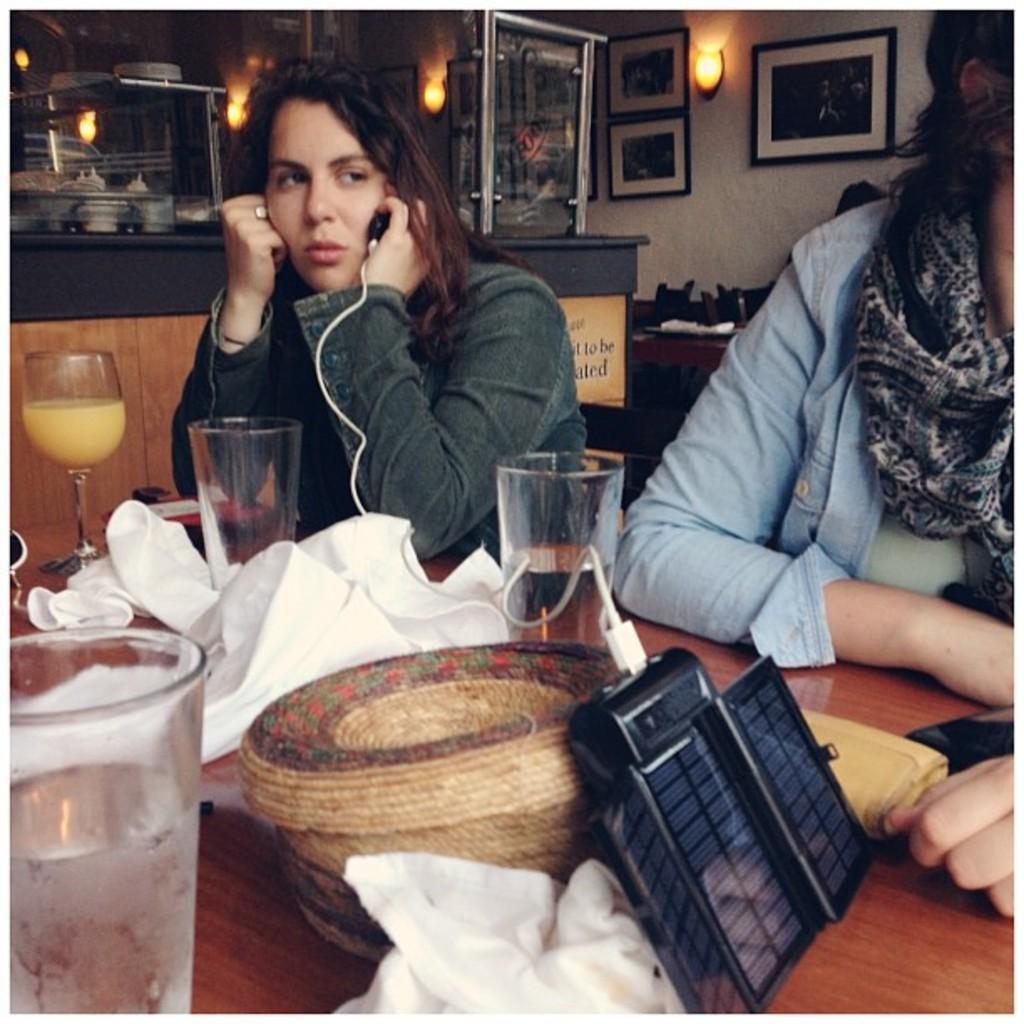Describe this image in one or two sentences. In this image I can see two people sitting in chairs in front of them there is a table on which I can see some glasses with beverages, napkins, and other objects and the person sitting on the left hand side is holding a USB cable connected to a gadget, behind them I can see a wooden cabin with a platform. I can see a some objects on the platform I can see lights and a wall with some wall paintings. 